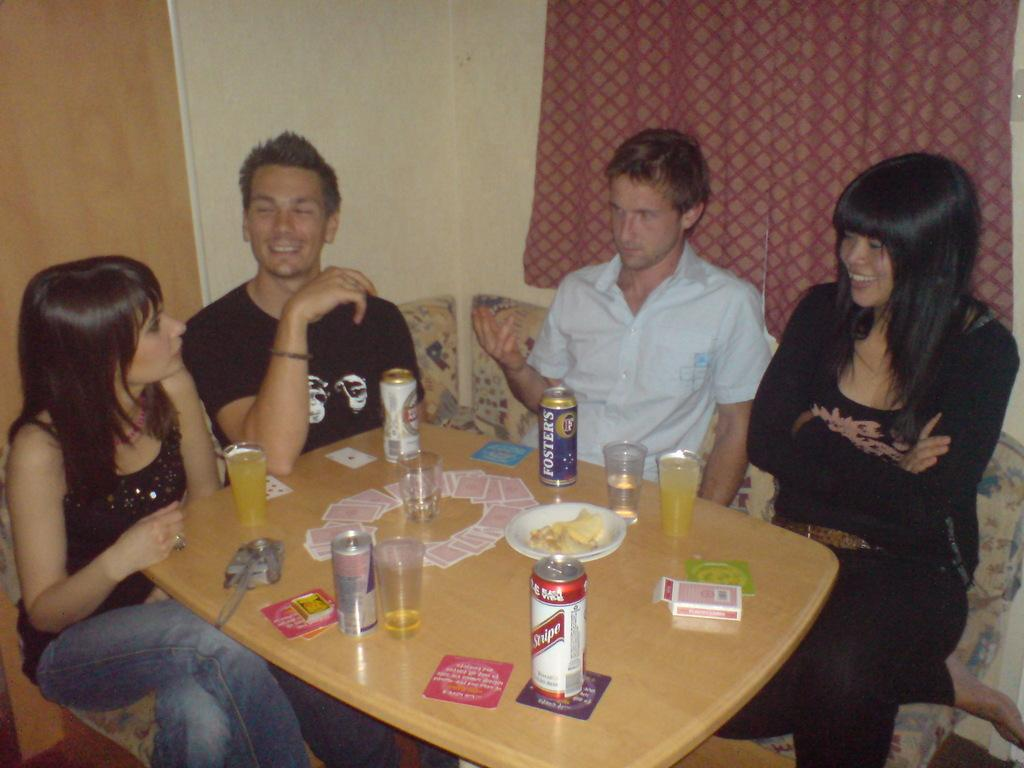What type of structure can be seen in the image? There is a wall in the image. What type of window treatment is present in the image? There is a curtain in the image. What type of furniture can be seen in the image? There are people sitting on sofas in the image. What type of surface is present in the image? There is a table in the image. What items can be seen on the table in the image? There is a matchbox, tins, glasses, and cards on the table. What year is depicted on the cards in the image? There is no year depicted on the cards in the image. What type of cover is present on the table in the image? There is no cover present on the table in the image. 